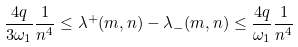<formula> <loc_0><loc_0><loc_500><loc_500>\frac { 4 q } { 3 \omega _ { 1 } } \frac { 1 } { n ^ { 4 } } \leq \lambda ^ { + } ( m , n ) - \lambda _ { - } ( m , n ) \leq \frac { 4 q } { \omega _ { 1 } } \frac { 1 } { n ^ { 4 } }</formula> 